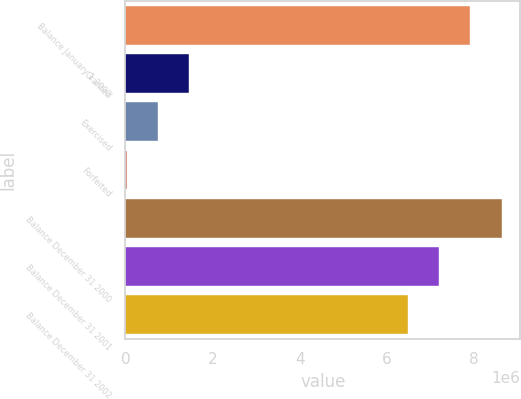Convert chart. <chart><loc_0><loc_0><loc_500><loc_500><bar_chart><fcel>Balance January 1 2000<fcel>Granted<fcel>Exercised<fcel>Forfeited<fcel>Balance December 31 2000<fcel>Balance December 31 2001<fcel>Balance December 31 2002<nl><fcel>7.90963e+06<fcel>1.46209e+06<fcel>744324<fcel>26560<fcel>8.62739e+06<fcel>7.19187e+06<fcel>6.4741e+06<nl></chart> 